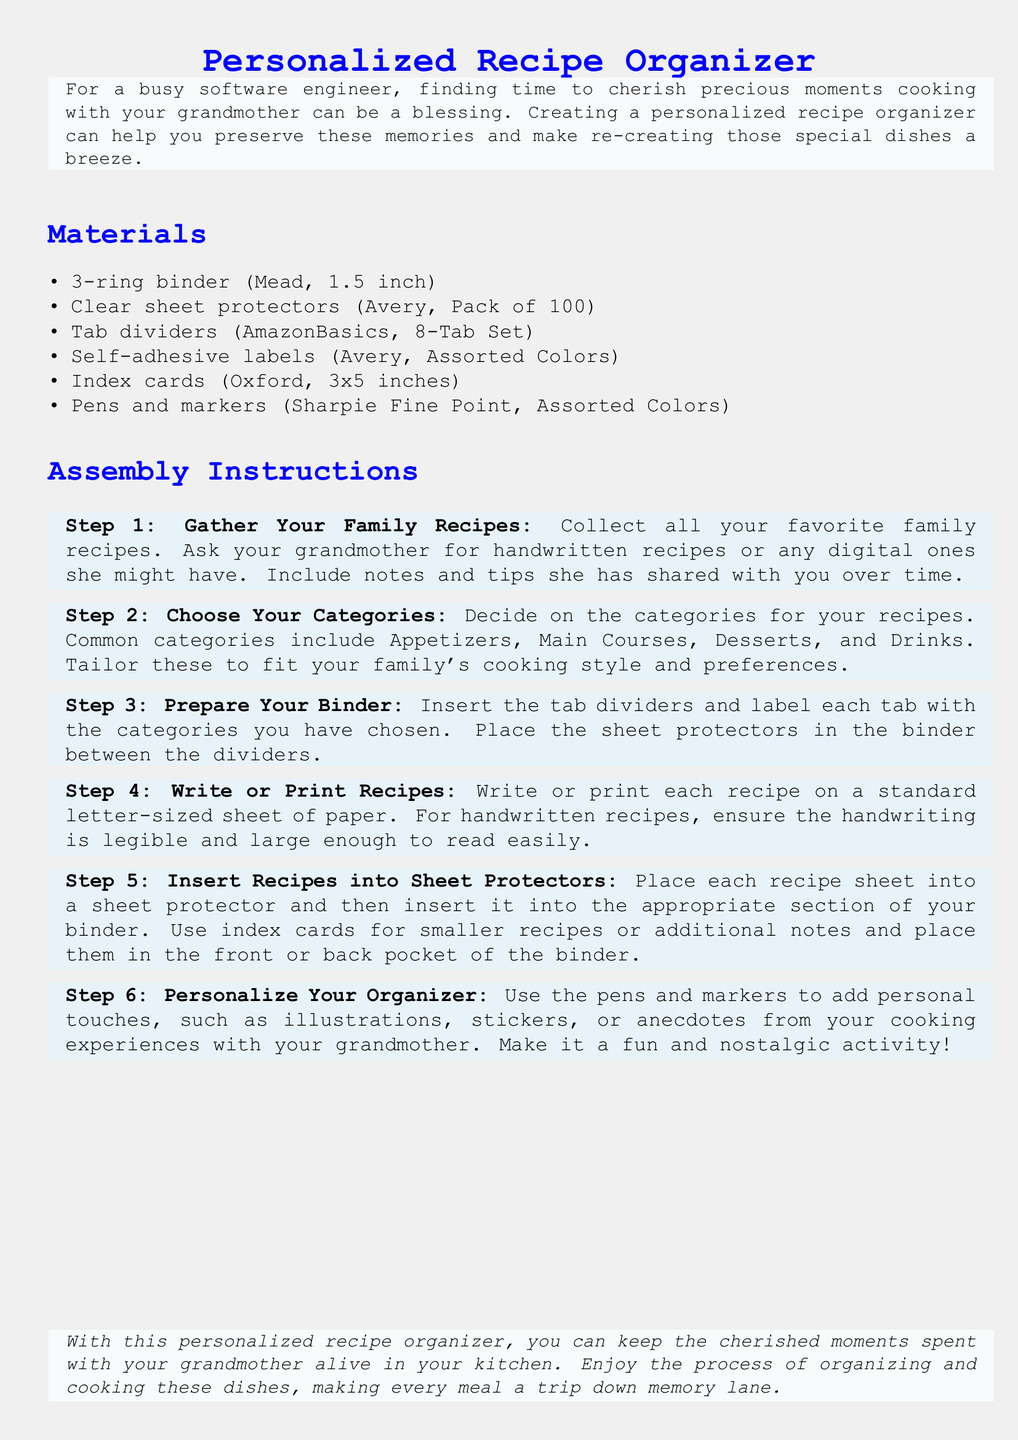What is the main purpose of the document? The main purpose is to help create a personalized recipe organizer with family recipes.
Answer: Creating a personalized recipe organizer How many tab dividers are included in the materials list? The number of tab dividers in the materials list specifies the quantity that should be used.
Answer: 8-Tab Set What is the size of the index cards recommended? The size of the index cards is specified to ensure they fit well in the binder.
Answer: 3x5 inches In which step do you write or print recipes? This step is specifically aimed at detailing how to handle recipes in the assembly process.
Answer: Step 4 What should you use to label each tab? This refers to the specific item needed for labeling in the assembly instructions.
Answer: Self-adhesive labels What category of recipes is NOT listed in the document? This question requires reasoning about what is commonly found in a recipe organizer and what is mentioned.
Answer: Salads What is suggested to use for personalizing the organizer? This is based on the specifics of how to enhance the recipe organizer visually and personally.
Answer: Pens and markers What activity is suggested in Step 6? This activity relates specifically to the last step in the instructions, highlighting its nature.
Answer: Personalize Your Organizer 